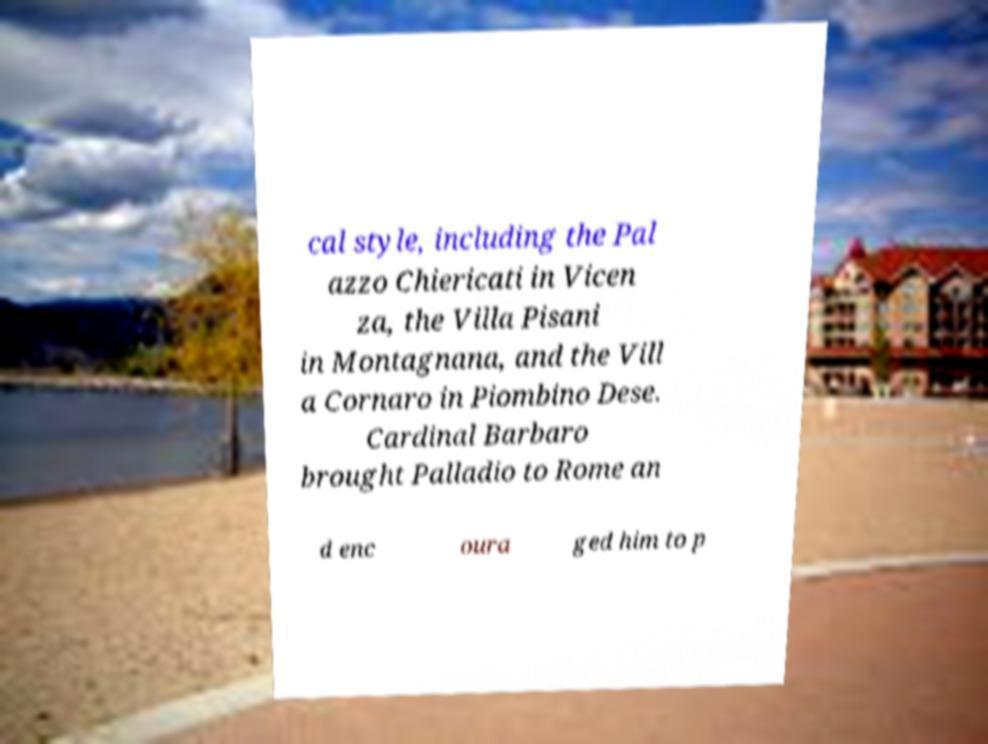What messages or text are displayed in this image? I need them in a readable, typed format. cal style, including the Pal azzo Chiericati in Vicen za, the Villa Pisani in Montagnana, and the Vill a Cornaro in Piombino Dese. Cardinal Barbaro brought Palladio to Rome an d enc oura ged him to p 